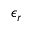Convert formula to latex. <formula><loc_0><loc_0><loc_500><loc_500>\epsilon _ { r }</formula> 